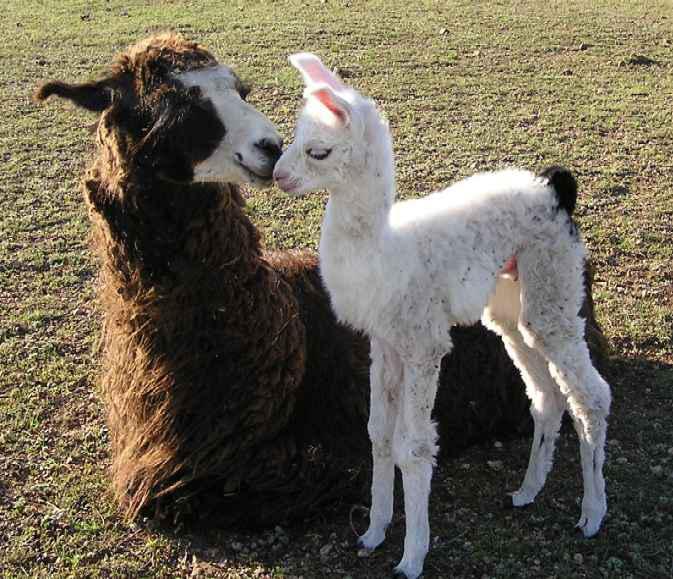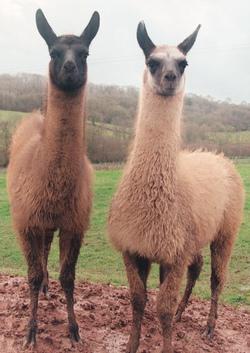The first image is the image on the left, the second image is the image on the right. Analyze the images presented: Is the assertion "In one of the images, two llamas are looking at the camera." valid? Answer yes or no. Yes. The first image is the image on the left, the second image is the image on the right. Examine the images to the left and right. Is the description "In at least one image there is a brown adult lama next to its black and white baby lama." accurate? Answer yes or no. Yes. 